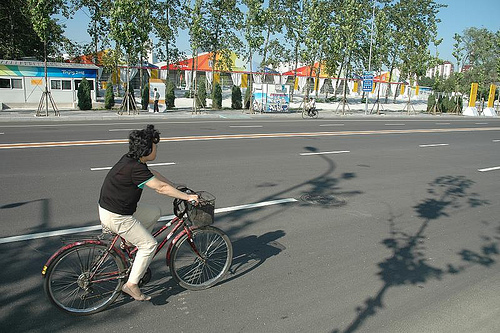<image>
Is the bicycle under the tree? No. The bicycle is not positioned under the tree. The vertical relationship between these objects is different. 